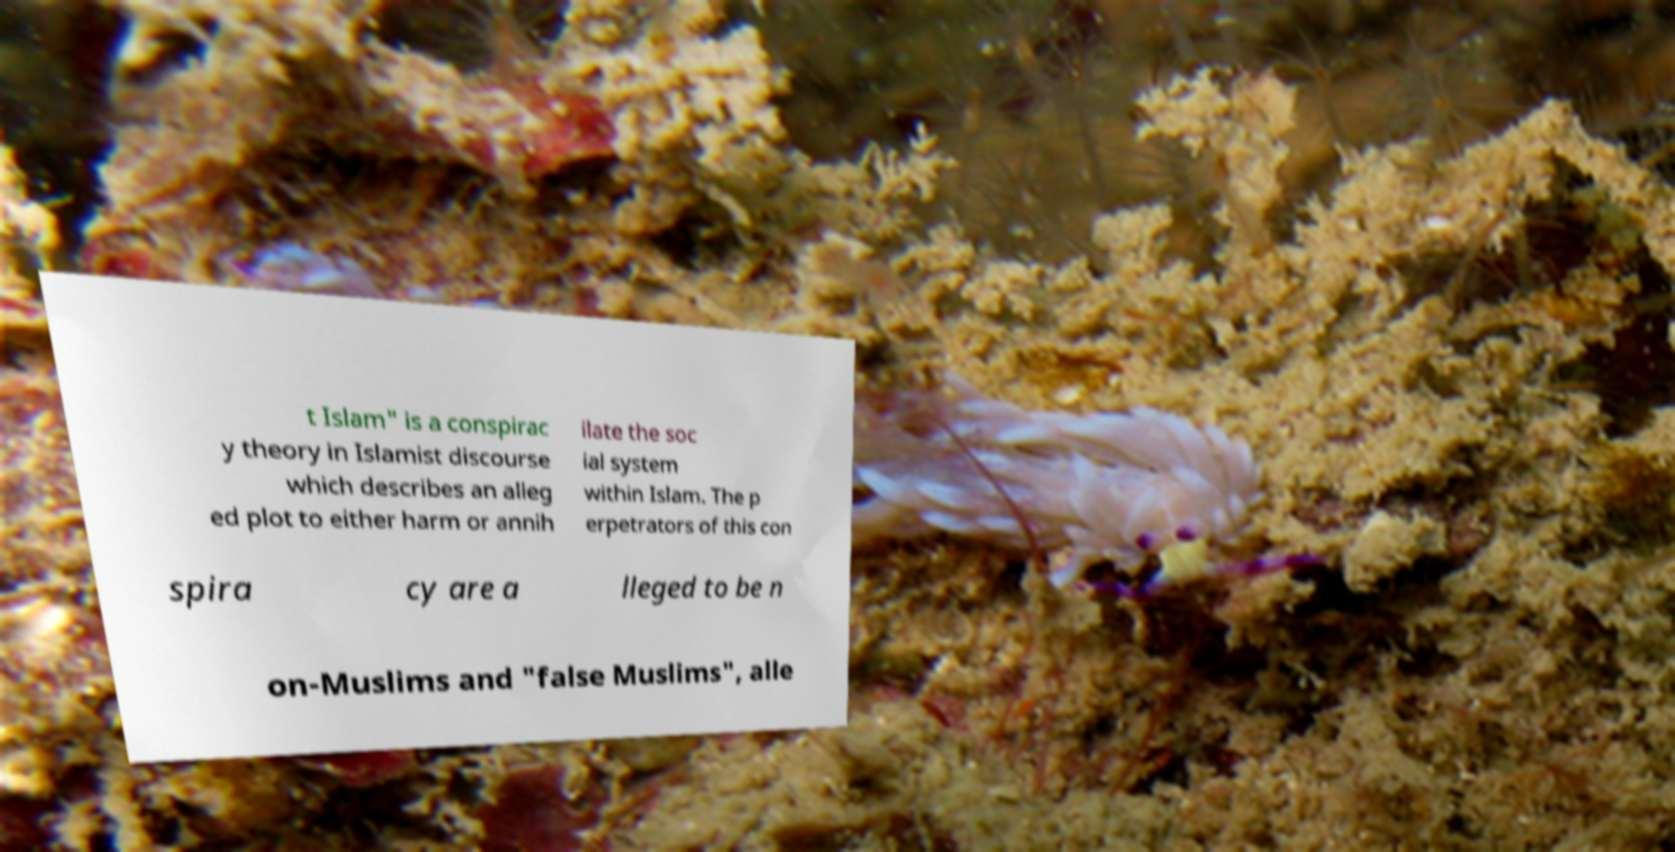Could you assist in decoding the text presented in this image and type it out clearly? t Islam" is a conspirac y theory in Islamist discourse which describes an alleg ed plot to either harm or annih ilate the soc ial system within Islam. The p erpetrators of this con spira cy are a lleged to be n on-Muslims and "false Muslims", alle 